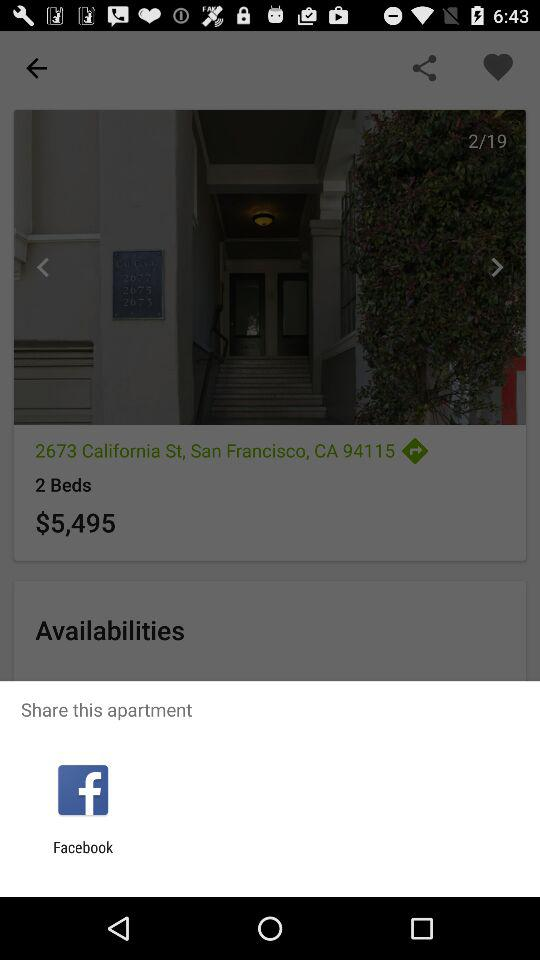How much is this apartment per night?
Answer the question using a single word or phrase. $5,495 